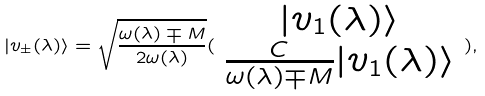Convert formula to latex. <formula><loc_0><loc_0><loc_500><loc_500>| v _ { \pm } ( \lambda ) \rangle = \sqrt { \frac { \omega ( \lambda ) \mp M } { 2 \omega ( \lambda ) } } ( \begin{array} { c } | v _ { 1 } ( \lambda ) \rangle \\ \frac { C } { \omega ( \lambda ) \mp M } | v _ { 1 } ( \lambda ) \rangle \end{array} ) ,</formula> 